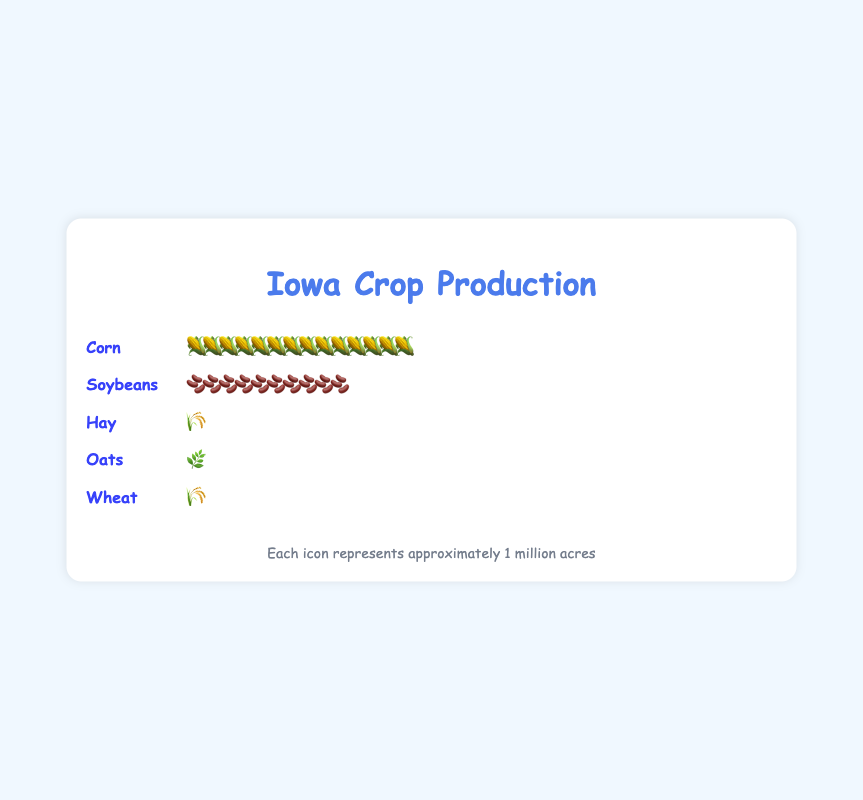What is the main title of the figure? The main title is usually at the top and clearly indicates the subject of the figure. In this case, the title specified is “Iowa Crop Production”.
Answer: Iowa Crop Production How many plant icons represent corn? Each icon represents 1 million acres, and we see 14 corn icons in the figure, which means 14 million acres of corn.
Answer: 14 Which crop has the least number of icons? By counting the number of icons for each crop, wheat has only 1 icon, which is the least number of icons among the crops shown.
Answer: Wheat How many more acres of corn are there compared to oats? Each icon represents 1 million acres. Corn has 14 icons and oats have 1 icon. The difference is calculated as 14 - 1 = 13 million acres.
Answer: 13 million acres What crop occupies the second largest area in Iowa? By comparing the number of icons, soybeans have 10 icons, which is the second largest after corn.
Answer: Soybeans What is the total number of plant icons representing crops in the figure? Adding up all the icons: Corn (14) + Soybeans (10) + Hay (1) + Oats (1) + Wheat (1) = 27 icons
Answer: 27 Which crop has the same number of icons as hay? Both hay and wheat have 1 icon each, representing the same acreage.
Answer: Wheat What percentage of the total acres is used for corn production? Corn has 14 icons, each representing 1 million acres, out of a total of 30 icons. The percentage is calculated as (14/30) * 100 = 46.67%.
Answer: 46.67% What is the combined acreage of hay and wheat? Both hay and wheat have 1 icon each, representing 1 million acres. The combined acreage is 1 + 1 = 2 million acres.
Answer: 2 million acres Is the acreage for soybeans more than twice that of hay? Soybeans have 10 icons, and hay has 1 icon. Twice the acreage of hay is 2 million acres, which is less than the 10 million acres for soybeans. Therefore, soybeans' acreage is more than twice that of hay.
Answer: Yes 